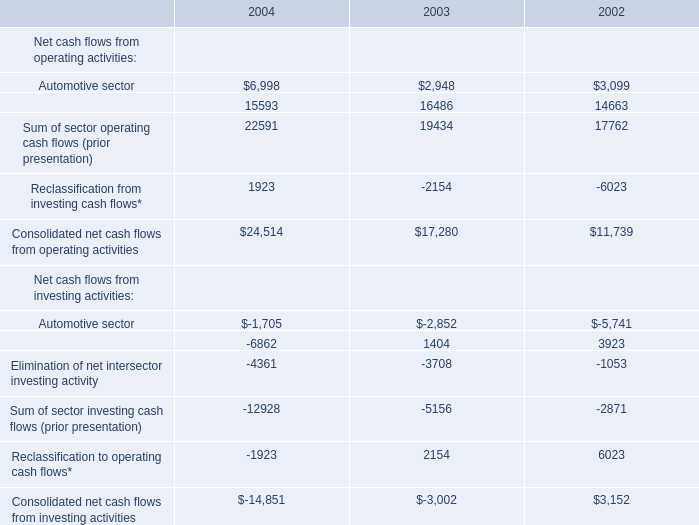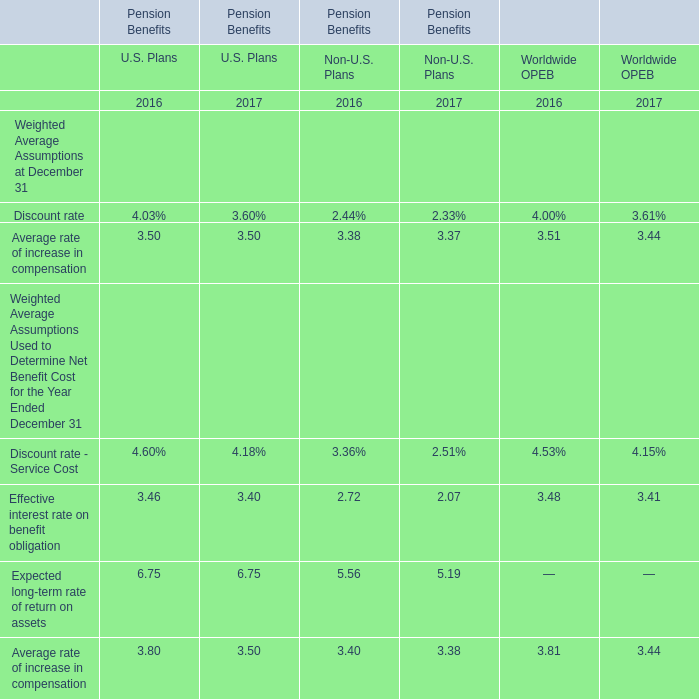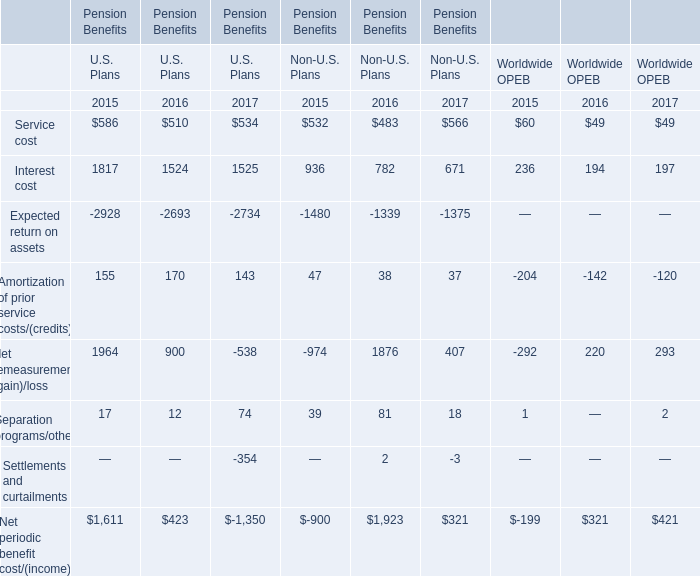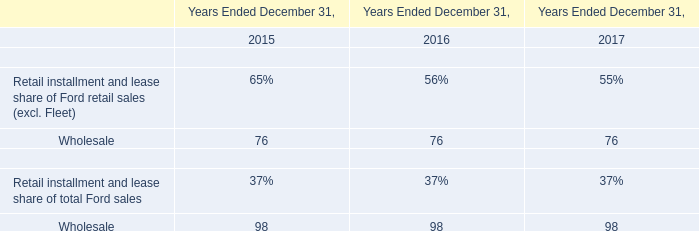What's the average of Expected return on assets of Pension Benefits U.S. Plans 2015, and Automotive sector of 2003 ? 
Computations: ((2928.0 + 2948.0) / 2)
Answer: 2938.0. 